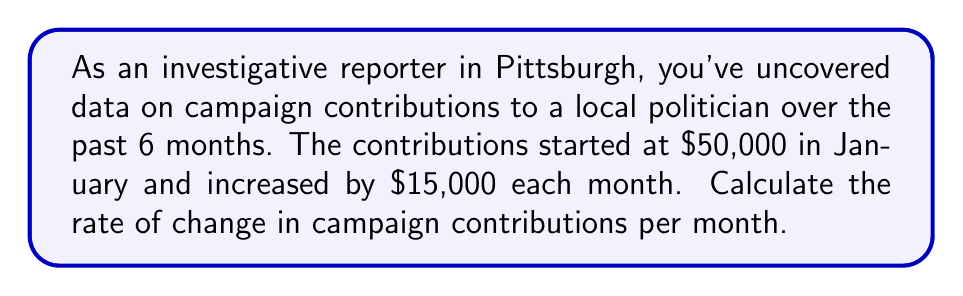Give your solution to this math problem. To calculate the rate of change, we need to determine how much the campaign contributions are increasing each month. Let's approach this step-by-step:

1. Identify the key information:
   - Initial contribution: $50,000 (January)
   - Monthly increase: $15,000
   - Time period: 6 months

2. The rate of change is the amount of increase per unit of time. In this case, it's the increase per month.

3. We're given that the contributions increase by $15,000 each month, so this is our rate of change.

4. To verify, we can calculate the contributions for each month:
   January: $50,000
   February: $50,000 + $15,000 = $65,000
   March: $65,000 + $15,000 = $80,000
   And so on...

5. We can express this mathematically as a linear equation:
   $$y = mx + b$$
   Where:
   $y$ = campaign contributions
   $m$ = rate of change (slope)
   $x$ = number of months since January
   $b$ = initial contribution in January

6. In this case, our equation would be:
   $$y = 15000x + 50000$$

7. The coefficient of $x$, which is 15000, represents our rate of change.

Therefore, the rate of change in campaign contributions is $15,000 per month.
Answer: $15,000 per month 